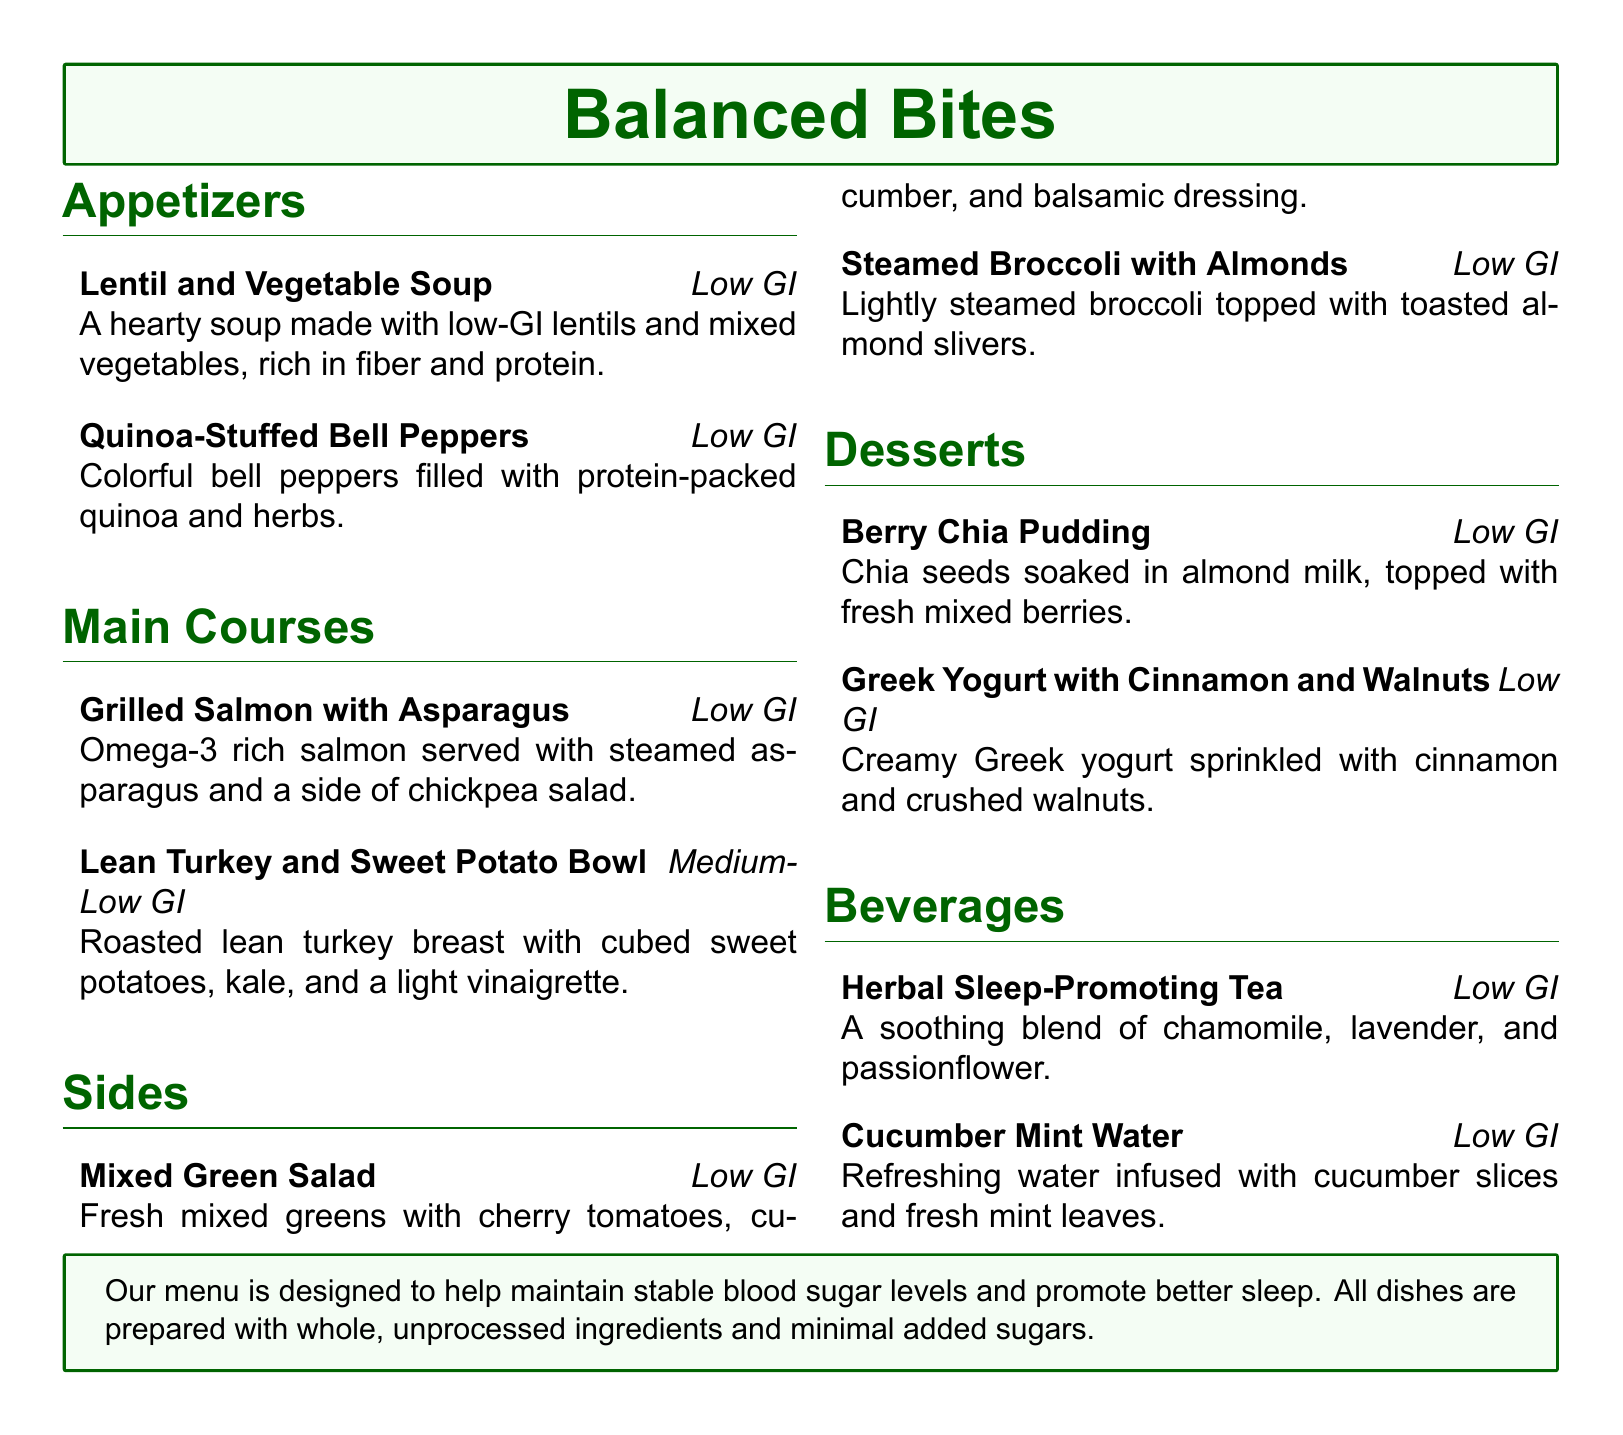What is the title of the menu? The title of the menu, as shown prominently at the top of the document, is the main highlight that represents the restaurant's offerings.
Answer: Balanced Bites How many appetizers are listed? The appetizers section contains a list, and by counting the items, we determine the total in that section.
Answer: 2 What is one of the main courses listed? The main courses section includes several items, and I can name one of them to illustrate choices available to diners.
Answer: Grilled Salmon with Asparagus Which dessert features chia seeds? The specific dessert among the options provided is identified based on the ingredients mentioned in the desserts section.
Answer: Berry Chia Pudding What type of tea is offered among the beverages? This beverage is highlighted for its soothing properties that align with sleep promotion, found in the beverages section.
Answer: Herbal Sleep-Promoting Tea What is the primary focus of the restaurant's menu? This is addressed in the last part of the document, summarizing the overall goal of the menu offerings.
Answer: Stable blood sugar levels Which side dish includes almonds? The contents of the sides section include various dishes, one of which specifically mentions the inclusion of almond toppings.
Answer: Steamed Broccoli with Almonds What ingredient is used in the Greek yogurt dessert? This dessert is noted for its specific toppings or flavorings, which can be found in the description of the dessert options.
Answer: Cinnamon and Walnuts What type of water is offered as a beverage? This beverage option is refreshing, and the description allows us to identify its main ingredients.
Answer: Cucumber Mint Water 